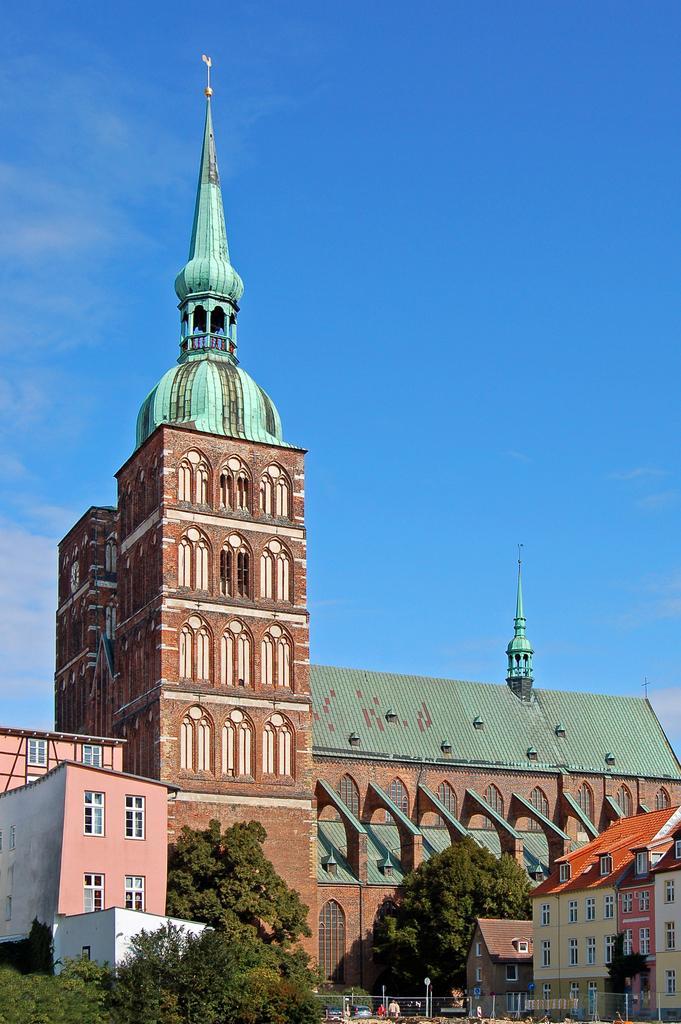Could you give a brief overview of what you see in this image? As we can see in the image there are buildings, trees, grass, few people here and there and sky. 